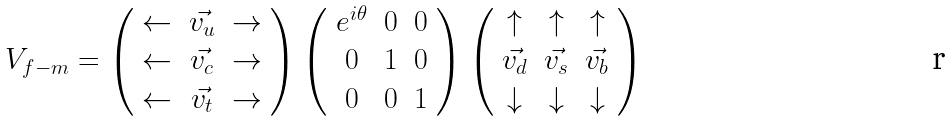Convert formula to latex. <formula><loc_0><loc_0><loc_500><loc_500>V _ { f - m } = \left ( \begin{array} { c c c } \leftarrow & \vec { v _ { u } } & \rightarrow \\ \leftarrow & \vec { v _ { c } } & \rightarrow \\ \leftarrow & \vec { v _ { t } } & \rightarrow \end{array} \right ) \left ( \begin{array} { c c c } e ^ { i \theta } & 0 & 0 \\ 0 & 1 & 0 \\ 0 & 0 & 1 \end{array} \right ) \left ( \begin{array} { c c c } \uparrow & \uparrow & \uparrow \\ \vec { v _ { d } } & \vec { v _ { s } } & \vec { v _ { b } } \\ \downarrow & \downarrow & \downarrow \end{array} \right )</formula> 